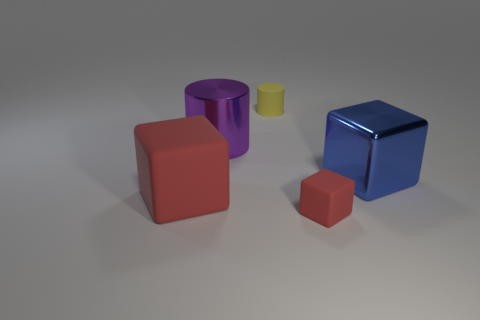There is a metal thing that is on the left side of the big blue metal object; is its shape the same as the rubber thing that is behind the large red matte object?
Make the answer very short. Yes. What number of objects are either things that are behind the large blue cube or large shiny objects right of the purple metal cylinder?
Ensure brevity in your answer.  3. How many other things are there of the same material as the large red block?
Your answer should be very brief. 2. Does the tiny thing that is behind the large blue metal cube have the same material as the big purple cylinder?
Your answer should be very brief. No. Is the number of rubber objects that are to the right of the small yellow thing greater than the number of yellow cylinders that are to the left of the big red cube?
Provide a short and direct response. Yes. How many things are red matte blocks that are on the right side of the tiny yellow matte thing or purple rubber spheres?
Ensure brevity in your answer.  1. The big object that is the same material as the blue cube is what shape?
Ensure brevity in your answer.  Cylinder. The object that is both in front of the purple cylinder and left of the small yellow rubber cylinder is what color?
Your response must be concise. Red. What number of cubes are matte things or small brown rubber objects?
Make the answer very short. 2. How many blue rubber spheres are the same size as the blue block?
Offer a very short reply. 0. 